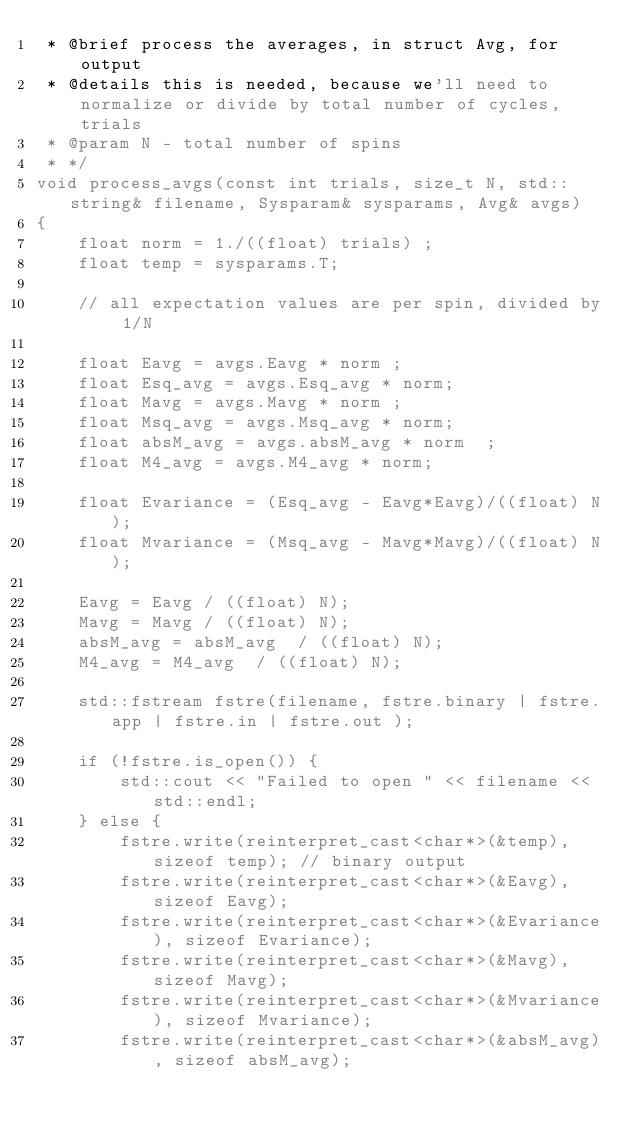<code> <loc_0><loc_0><loc_500><loc_500><_Cuda_> * @brief process the averages, in struct Avg, for output 
 * @details this is needed, because we'll need to normalize or divide by total number of cycles, trials  
 * @param N - total number of spins 
 * */ 
void process_avgs(const int trials, size_t N, std::string& filename, Sysparam& sysparams, Avg& avgs) 
{
	float norm = 1./((float) trials) ; 
	float temp = sysparams.T; 

	// all expectation values are per spin, divided by 1/N
	
	float Eavg = avgs.Eavg * norm ; 
	float Esq_avg = avgs.Esq_avg * norm; 
	float Mavg = avgs.Mavg * norm ; 
	float Msq_avg = avgs.Msq_avg * norm; 
	float absM_avg = avgs.absM_avg * norm  ; 
	float M4_avg = avgs.M4_avg * norm; 
	
	float Evariance = (Esq_avg - Eavg*Eavg)/((float) N); 
	float Mvariance = (Msq_avg - Mavg*Mavg)/((float) N);  

	Eavg = Eavg / ((float) N); 
	Mavg = Mavg / ((float) N); 
	absM_avg = absM_avg  / ((float) N); 
	M4_avg = M4_avg  / ((float) N); 

	std::fstream fstre(filename, fstre.binary | fstre.app | fstre.in | fstre.out );
	
	if (!fstre.is_open()) {
		std::cout << "Failed to open " << filename << std::endl; 
	} else {
		fstre.write(reinterpret_cast<char*>(&temp), sizeof temp); // binary output  
		fstre.write(reinterpret_cast<char*>(&Eavg), sizeof Eavg); 
		fstre.write(reinterpret_cast<char*>(&Evariance), sizeof Evariance); 
		fstre.write(reinterpret_cast<char*>(&Mavg), sizeof Mavg); 
		fstre.write(reinterpret_cast<char*>(&Mvariance), sizeof Mvariance);
		fstre.write(reinterpret_cast<char*>(&absM_avg), sizeof absM_avg); </code> 